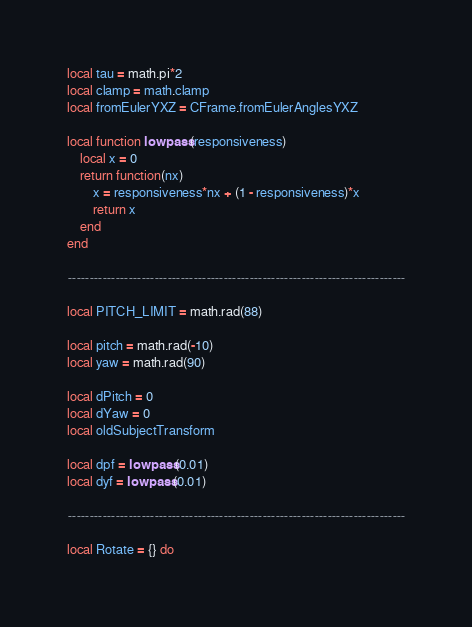<code> <loc_0><loc_0><loc_500><loc_500><_Lua_>
local tau = math.pi*2
local clamp = math.clamp
local fromEulerYXZ = CFrame.fromEulerAnglesYXZ

local function lowpass(responsiveness)
	local x = 0
	return function(nx)
		x = responsiveness*nx + (1 - responsiveness)*x
		return x
	end
end

------------------------------------------------------------------------------

local PITCH_LIMIT = math.rad(88)

local pitch = math.rad(-10)
local yaw = math.rad(90)

local dPitch = 0
local dYaw = 0
local oldSubjectTransform

local dpf = lowpass(0.01)
local dyf = lowpass(0.01)

------------------------------------------------------------------------------

local Rotate = {} do</code> 